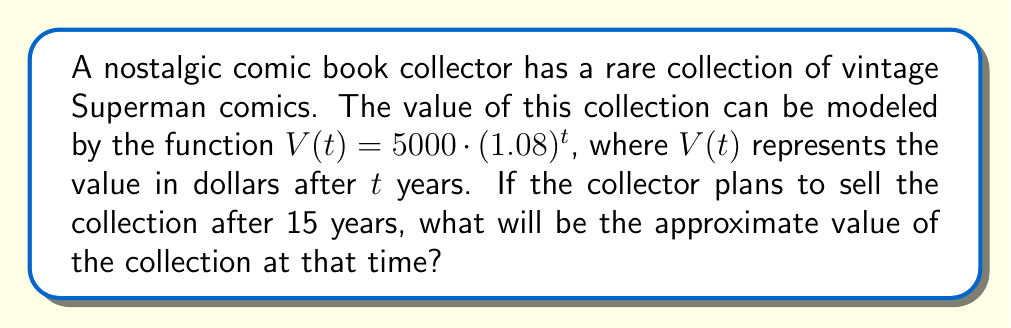Help me with this question. To solve this problem, we need to use the given function and substitute the appropriate value for $t$. Let's break it down step by step:

1) The given function is $V(t) = 5000 \cdot (1.08)^t$
   
   Where:
   - $V(t)$ is the value of the collection in dollars
   - $5000 is the initial value of the collection
   - $1.08 represents an 8% annual increase in value
   - $t$ is the number of years

2) We want to find the value after 15 years, so we substitute $t = 15$:

   $$V(15) = 5000 \cdot (1.08)^{15}$$

3) Now, let's calculate this step by step:
   
   $$V(15) = 5000 \cdot (1.08)^{15}$$
   $$= 5000 \cdot 3.17191...$$
   $$= 15,859.55...$$

4) Rounding to the nearest dollar:

   $$V(15) \approx 15,860$$

Therefore, after 15 years, the comic book collection will be worth approximately $15,860.
Answer: $15,860 